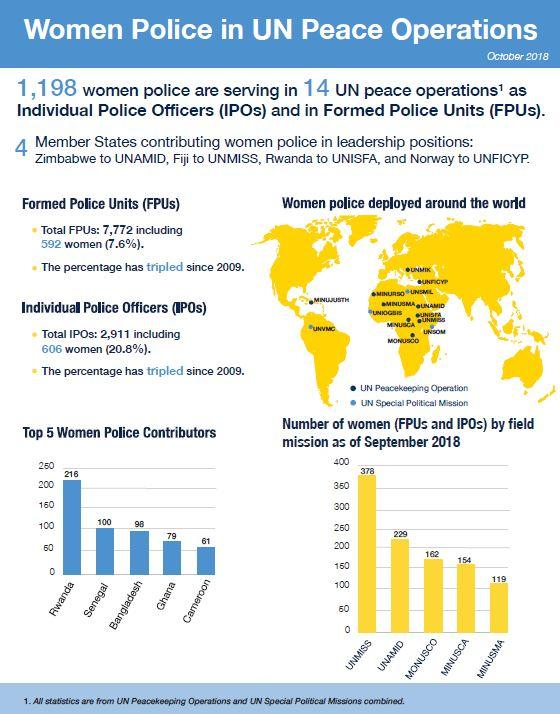Indicate a few pertinent items in this graphic. As of September 2018, 119 women had been deployed as FPUs and IPOs in the MINUSMA mission. According to the latest data from October 2018, it is Rwanda that has the highest number of women police contributors in UN peace operations. As of September 2018, the United Nations Mission in South Sudan (UNMISS) deployed the highest number of women as both Female Police Officers (FPUs) and Internally Displaced Persons (IDPs) when compared to other UN missions. The United Nations Mission in Mali (MINUSMA) deployed the fewest number of women in the form of Female Police Officers (FPUs) and International Police Officers (IPOs) as of September 2018. As of October 2018, there were 79 female police contributors participating in UN peace operations in Ghana. 